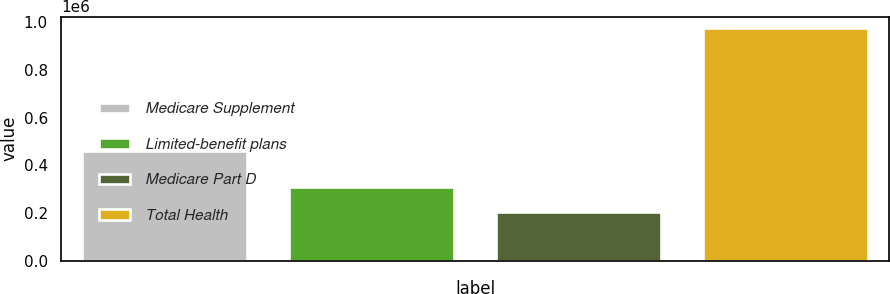<chart> <loc_0><loc_0><loc_500><loc_500><bar_chart><fcel>Medicare Supplement<fcel>Limited-benefit plans<fcel>Medicare Part D<fcel>Total Health<nl><fcel>461386<fcel>308899<fcel>203340<fcel>973625<nl></chart> 